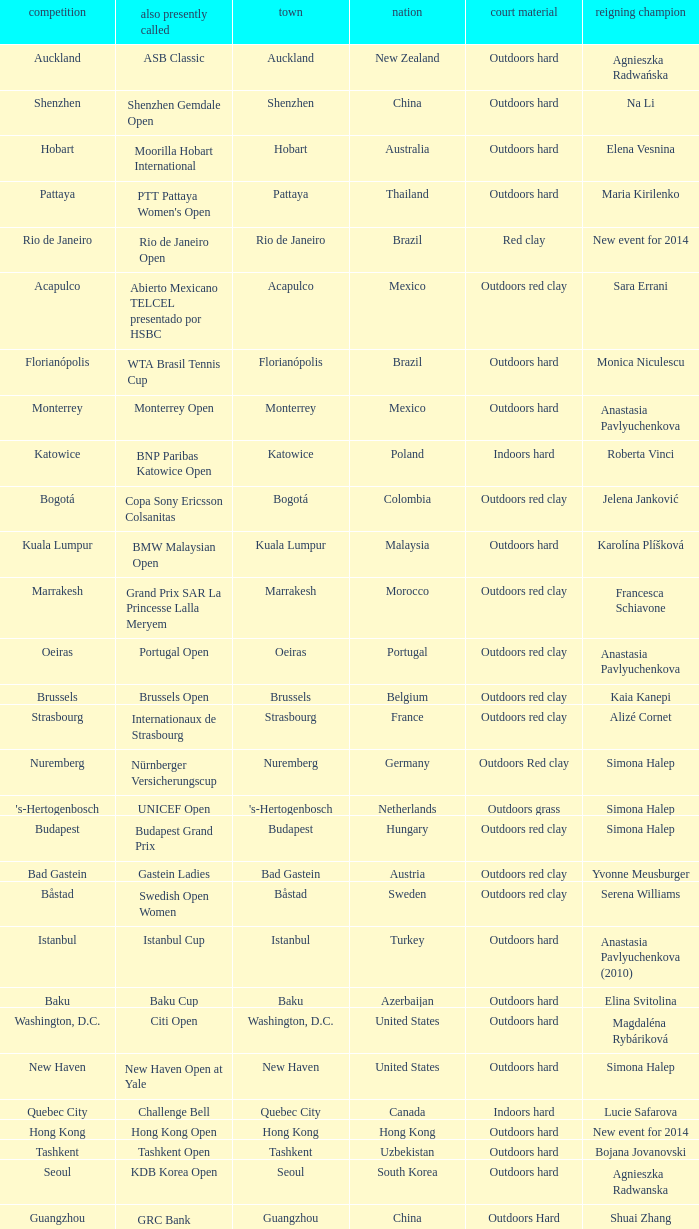What tournament is in katowice? Katowice. 